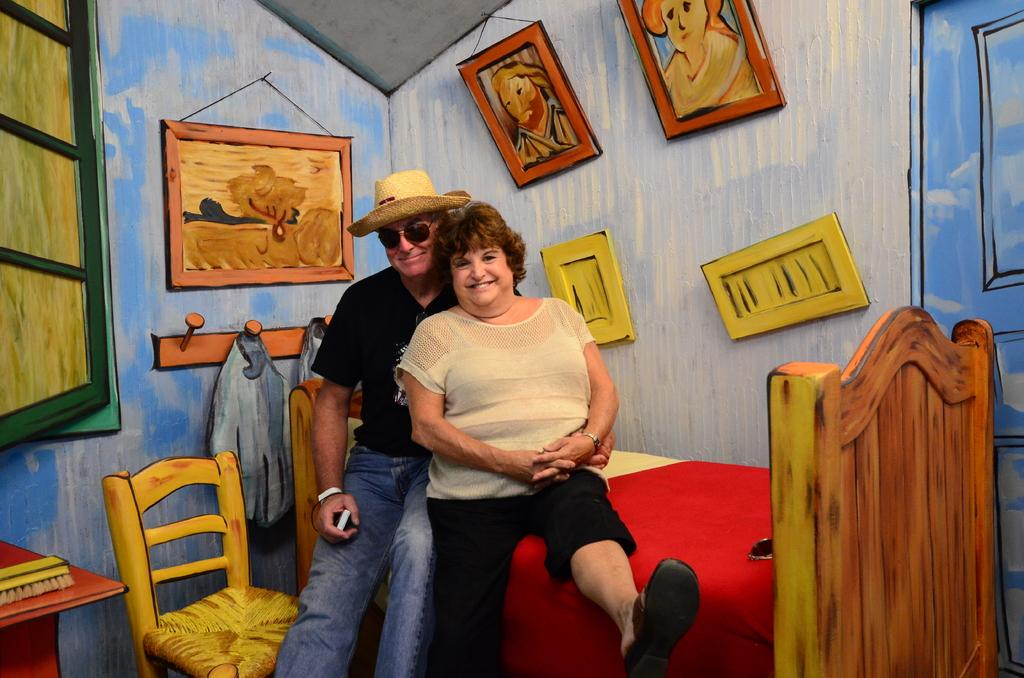Who is present in the image? There is a man and a woman in the image. What are the man and woman doing in the image? The man and woman are seated on a bed and smiling. What can be seen on the walls in the image? There are paintings visible in the image. What type of business is the man conducting in the image? There is no indication of any business activity in the image; the man and woman are simply seated on a bed and smiling. How many ducks are present in the image? There are no ducks present in the image. 